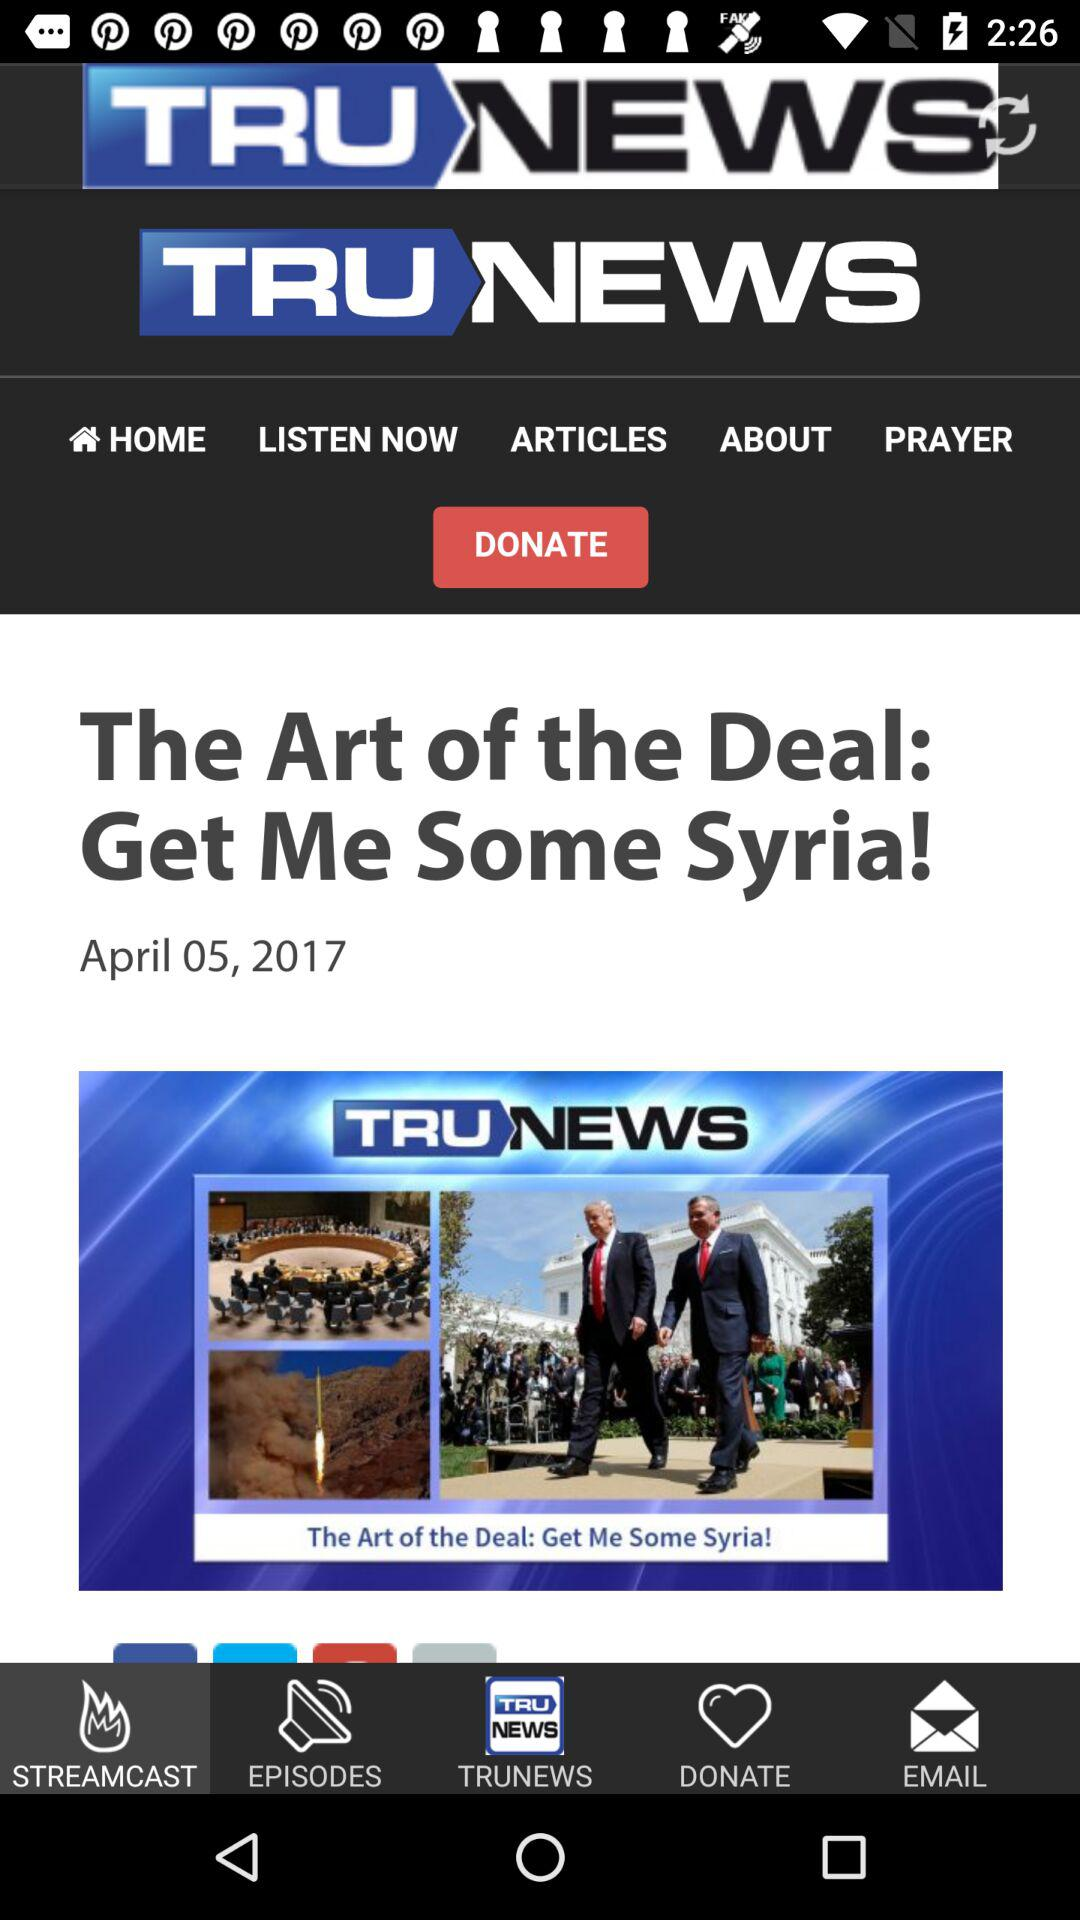Which tab is selected? The selected tab is "STREAMCAST". 